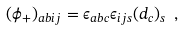<formula> <loc_0><loc_0><loc_500><loc_500>( \phi _ { + } ) _ { a b i j } = \epsilon _ { a b c } \epsilon _ { i j s } ( { d } _ { c } ) _ { s } \ ,</formula> 